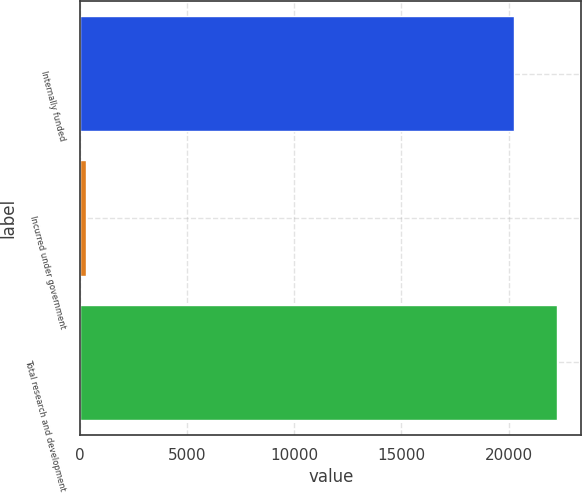Convert chart to OTSL. <chart><loc_0><loc_0><loc_500><loc_500><bar_chart><fcel>Internally funded<fcel>Incurred under government<fcel>Total research and development<nl><fcel>20259<fcel>293<fcel>22284.9<nl></chart> 